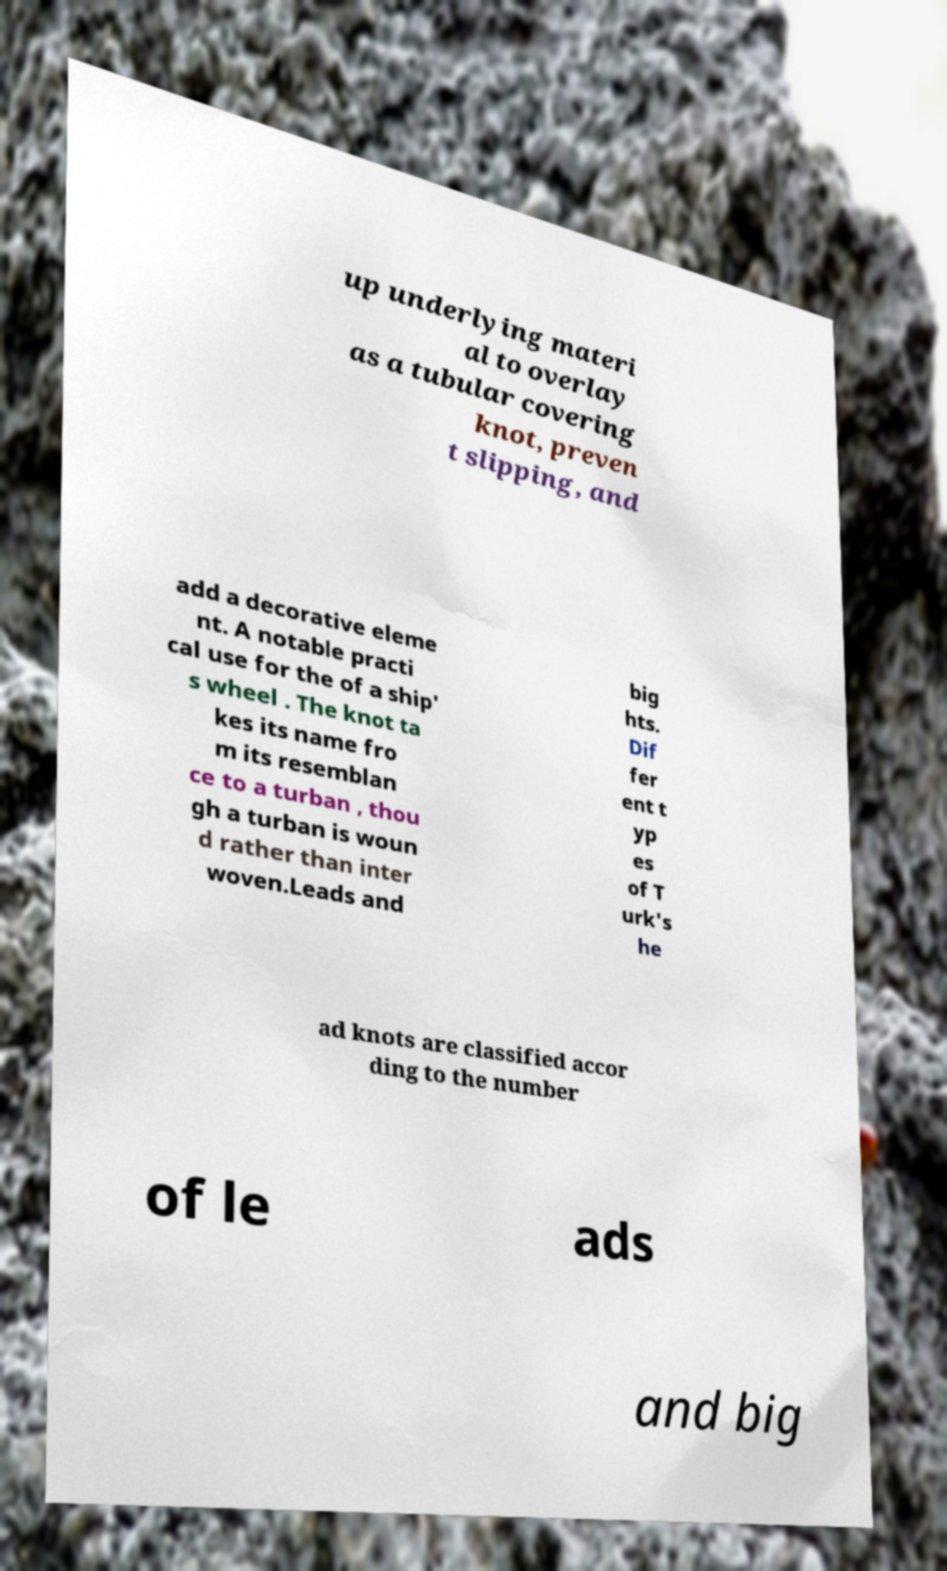I need the written content from this picture converted into text. Can you do that? up underlying materi al to overlay as a tubular covering knot, preven t slipping, and add a decorative eleme nt. A notable practi cal use for the of a ship' s wheel . The knot ta kes its name fro m its resemblan ce to a turban , thou gh a turban is woun d rather than inter woven.Leads and big hts. Dif fer ent t yp es of T urk's he ad knots are classified accor ding to the number of le ads and big 